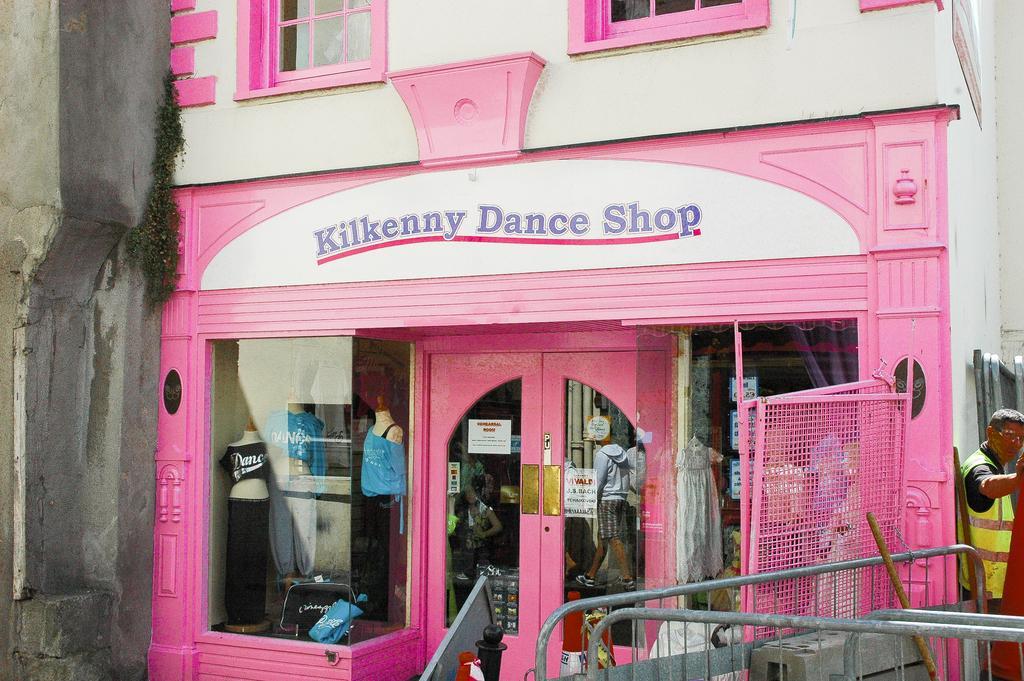In one or two sentences, can you explain what this image depicts? In this image we can see a building. At the bottom there is a store and we can see mannequins. In the center there is a door and we can see people's reflection on the glass door. On the right there is a man. At the bottom we can see a fence. 